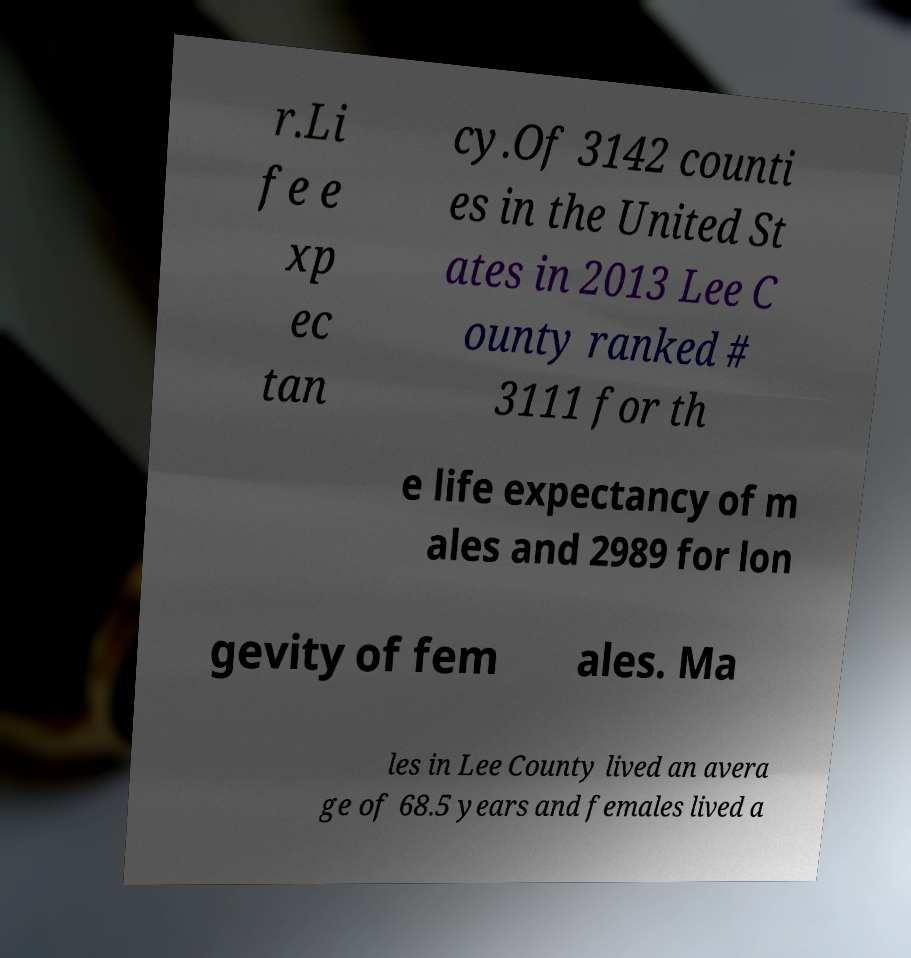What messages or text are displayed in this image? I need them in a readable, typed format. r.Li fe e xp ec tan cy.Of 3142 counti es in the United St ates in 2013 Lee C ounty ranked # 3111 for th e life expectancy of m ales and 2989 for lon gevity of fem ales. Ma les in Lee County lived an avera ge of 68.5 years and females lived a 